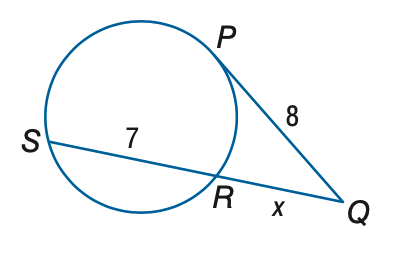Question: P Q is tangent to the circle. Find x. Round to the nearest tenth.
Choices:
A. 4.2
B. 5.2
C. 6.2
D. 7.2
Answer with the letter. Answer: B 